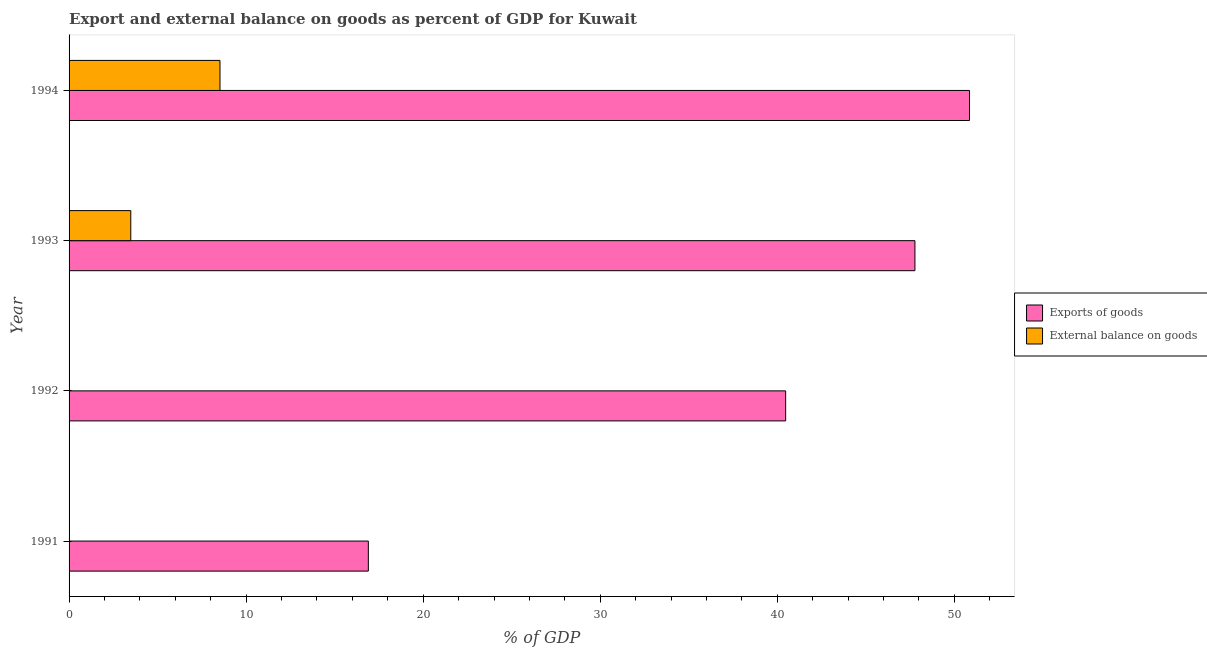Are the number of bars per tick equal to the number of legend labels?
Offer a very short reply. No. Are the number of bars on each tick of the Y-axis equal?
Ensure brevity in your answer.  No. How many bars are there on the 3rd tick from the top?
Provide a short and direct response. 1. How many bars are there on the 1st tick from the bottom?
Provide a succinct answer. 1. What is the label of the 4th group of bars from the top?
Your answer should be compact. 1991. What is the external balance on goods as percentage of gdp in 1994?
Ensure brevity in your answer.  8.52. Across all years, what is the maximum export of goods as percentage of gdp?
Offer a terse response. 50.85. What is the total export of goods as percentage of gdp in the graph?
Make the answer very short. 156. What is the difference between the export of goods as percentage of gdp in 1992 and that in 1994?
Offer a terse response. -10.38. What is the difference between the export of goods as percentage of gdp in 1991 and the external balance on goods as percentage of gdp in 1992?
Provide a short and direct response. 16.9. What is the average external balance on goods as percentage of gdp per year?
Provide a short and direct response. 3. In the year 1994, what is the difference between the external balance on goods as percentage of gdp and export of goods as percentage of gdp?
Your response must be concise. -42.33. What is the ratio of the export of goods as percentage of gdp in 1991 to that in 1994?
Ensure brevity in your answer.  0.33. Is the export of goods as percentage of gdp in 1992 less than that in 1993?
Your response must be concise. Yes. What is the difference between the highest and the second highest export of goods as percentage of gdp?
Provide a short and direct response. 3.08. What is the difference between the highest and the lowest external balance on goods as percentage of gdp?
Provide a short and direct response. 8.52. Is the sum of the export of goods as percentage of gdp in 1992 and 1994 greater than the maximum external balance on goods as percentage of gdp across all years?
Keep it short and to the point. Yes. How many years are there in the graph?
Offer a terse response. 4. Are the values on the major ticks of X-axis written in scientific E-notation?
Your answer should be very brief. No. How many legend labels are there?
Provide a succinct answer. 2. How are the legend labels stacked?
Make the answer very short. Vertical. What is the title of the graph?
Make the answer very short. Export and external balance on goods as percent of GDP for Kuwait. What is the label or title of the X-axis?
Your answer should be very brief. % of GDP. What is the label or title of the Y-axis?
Keep it short and to the point. Year. What is the % of GDP in Exports of goods in 1991?
Give a very brief answer. 16.9. What is the % of GDP of Exports of goods in 1992?
Offer a very short reply. 40.47. What is the % of GDP of Exports of goods in 1993?
Keep it short and to the point. 47.77. What is the % of GDP in External balance on goods in 1993?
Ensure brevity in your answer.  3.49. What is the % of GDP in Exports of goods in 1994?
Give a very brief answer. 50.85. What is the % of GDP of External balance on goods in 1994?
Provide a succinct answer. 8.52. Across all years, what is the maximum % of GDP in Exports of goods?
Provide a succinct answer. 50.85. Across all years, what is the maximum % of GDP in External balance on goods?
Provide a succinct answer. 8.52. Across all years, what is the minimum % of GDP in Exports of goods?
Your response must be concise. 16.9. Across all years, what is the minimum % of GDP of External balance on goods?
Offer a very short reply. 0. What is the total % of GDP of Exports of goods in the graph?
Your response must be concise. 156. What is the total % of GDP in External balance on goods in the graph?
Provide a short and direct response. 12.01. What is the difference between the % of GDP of Exports of goods in 1991 and that in 1992?
Ensure brevity in your answer.  -23.57. What is the difference between the % of GDP in Exports of goods in 1991 and that in 1993?
Keep it short and to the point. -30.87. What is the difference between the % of GDP of Exports of goods in 1991 and that in 1994?
Give a very brief answer. -33.95. What is the difference between the % of GDP in Exports of goods in 1992 and that in 1993?
Offer a terse response. -7.3. What is the difference between the % of GDP of Exports of goods in 1992 and that in 1994?
Offer a very short reply. -10.38. What is the difference between the % of GDP in Exports of goods in 1993 and that in 1994?
Give a very brief answer. -3.08. What is the difference between the % of GDP in External balance on goods in 1993 and that in 1994?
Make the answer very short. -5.04. What is the difference between the % of GDP of Exports of goods in 1991 and the % of GDP of External balance on goods in 1993?
Your answer should be very brief. 13.42. What is the difference between the % of GDP of Exports of goods in 1991 and the % of GDP of External balance on goods in 1994?
Offer a very short reply. 8.38. What is the difference between the % of GDP of Exports of goods in 1992 and the % of GDP of External balance on goods in 1993?
Offer a terse response. 36.98. What is the difference between the % of GDP in Exports of goods in 1992 and the % of GDP in External balance on goods in 1994?
Provide a succinct answer. 31.95. What is the difference between the % of GDP in Exports of goods in 1993 and the % of GDP in External balance on goods in 1994?
Ensure brevity in your answer.  39.25. What is the average % of GDP in Exports of goods per year?
Your answer should be very brief. 39. What is the average % of GDP in External balance on goods per year?
Ensure brevity in your answer.  3. In the year 1993, what is the difference between the % of GDP of Exports of goods and % of GDP of External balance on goods?
Give a very brief answer. 44.29. In the year 1994, what is the difference between the % of GDP in Exports of goods and % of GDP in External balance on goods?
Make the answer very short. 42.33. What is the ratio of the % of GDP of Exports of goods in 1991 to that in 1992?
Ensure brevity in your answer.  0.42. What is the ratio of the % of GDP of Exports of goods in 1991 to that in 1993?
Ensure brevity in your answer.  0.35. What is the ratio of the % of GDP in Exports of goods in 1991 to that in 1994?
Your answer should be compact. 0.33. What is the ratio of the % of GDP in Exports of goods in 1992 to that in 1993?
Provide a short and direct response. 0.85. What is the ratio of the % of GDP in Exports of goods in 1992 to that in 1994?
Give a very brief answer. 0.8. What is the ratio of the % of GDP in Exports of goods in 1993 to that in 1994?
Your answer should be compact. 0.94. What is the ratio of the % of GDP of External balance on goods in 1993 to that in 1994?
Keep it short and to the point. 0.41. What is the difference between the highest and the second highest % of GDP in Exports of goods?
Provide a succinct answer. 3.08. What is the difference between the highest and the lowest % of GDP in Exports of goods?
Provide a succinct answer. 33.95. What is the difference between the highest and the lowest % of GDP in External balance on goods?
Your answer should be compact. 8.52. 